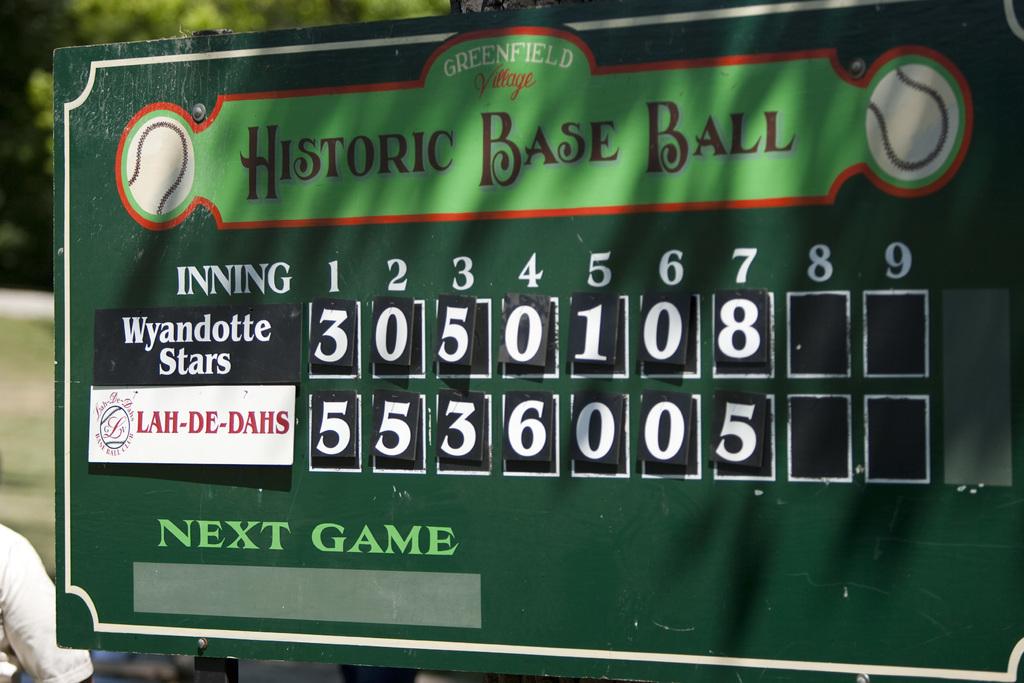How many runs did the lah-de-dahs score in the 4th inning?
Your response must be concise. 6. What is the team on the the top?
Ensure brevity in your answer.  Wyandotte stars. 